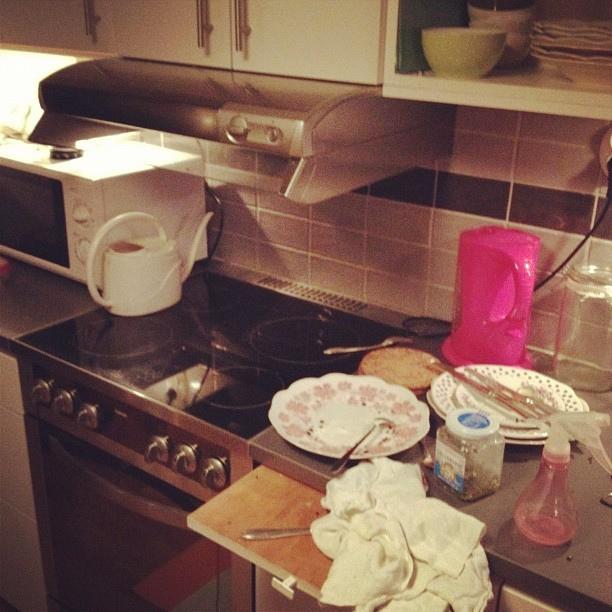How many appliances are there?
Quick response, please. 2. What color is the stove top?
Keep it brief. Black. Does this kitchen need cleaning?
Quick response, please. Yes. 